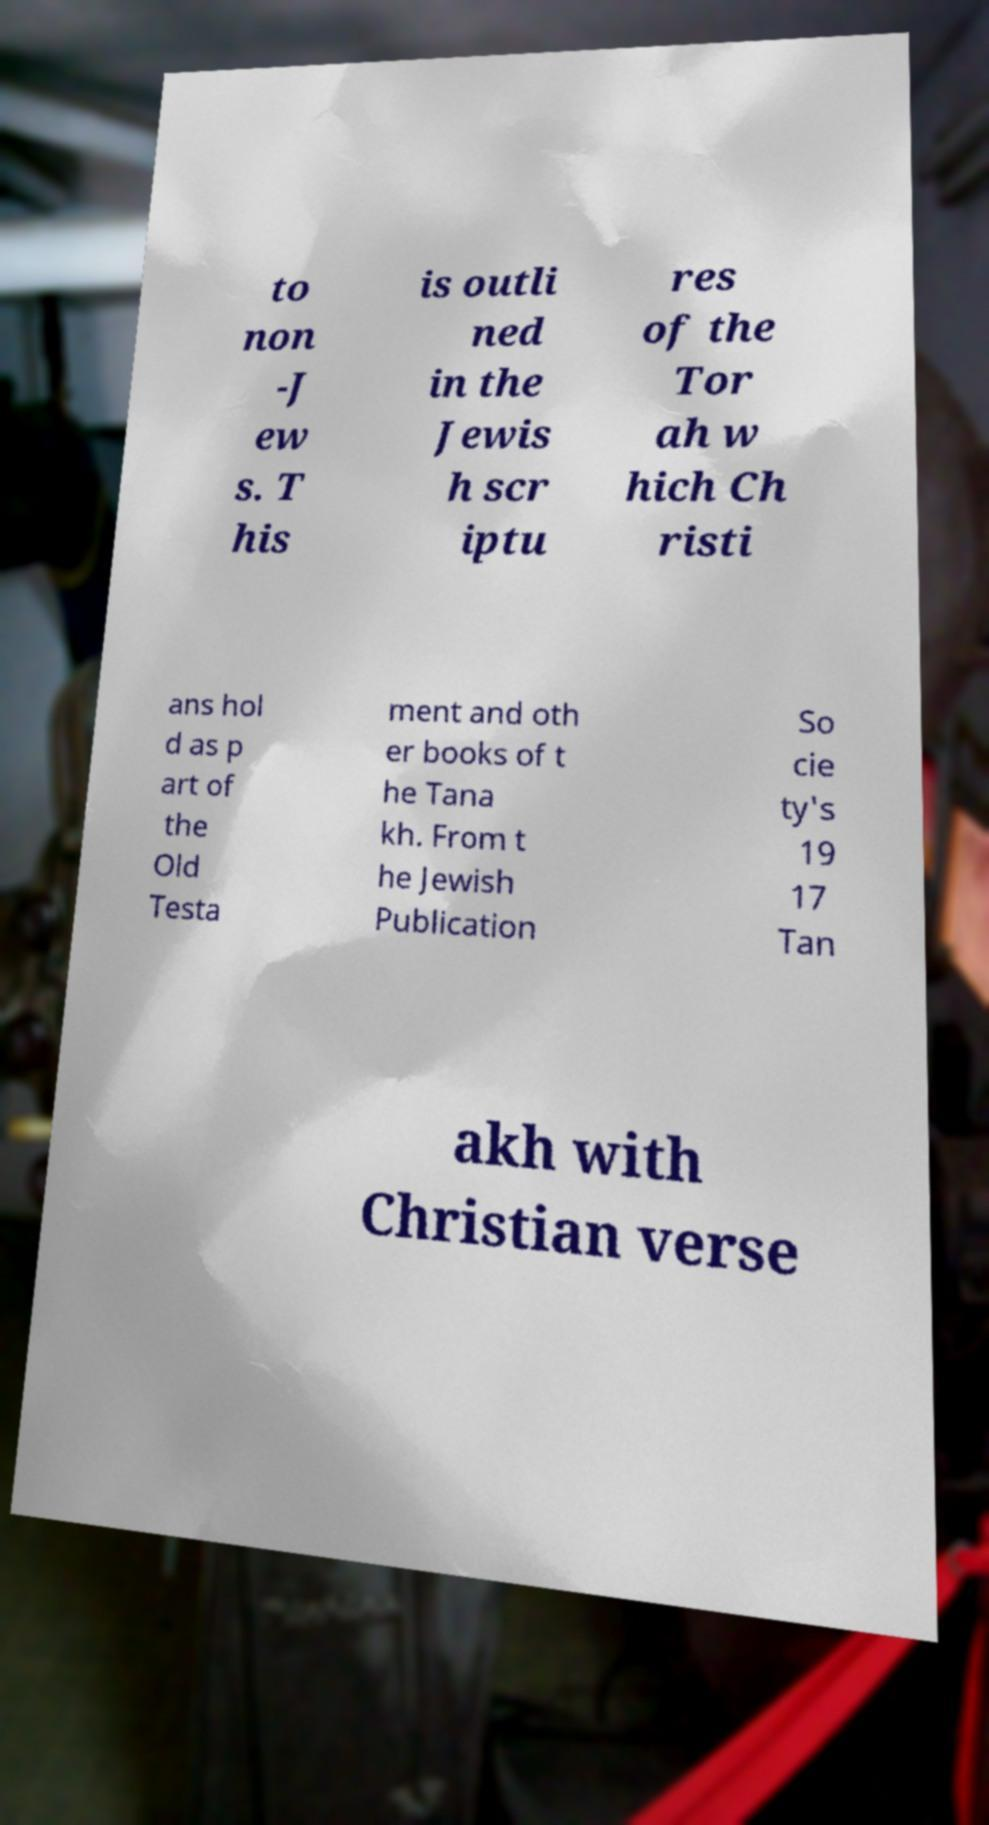Please identify and transcribe the text found in this image. to non -J ew s. T his is outli ned in the Jewis h scr iptu res of the Tor ah w hich Ch risti ans hol d as p art of the Old Testa ment and oth er books of t he Tana kh. From t he Jewish Publication So cie ty's 19 17 Tan akh with Christian verse 